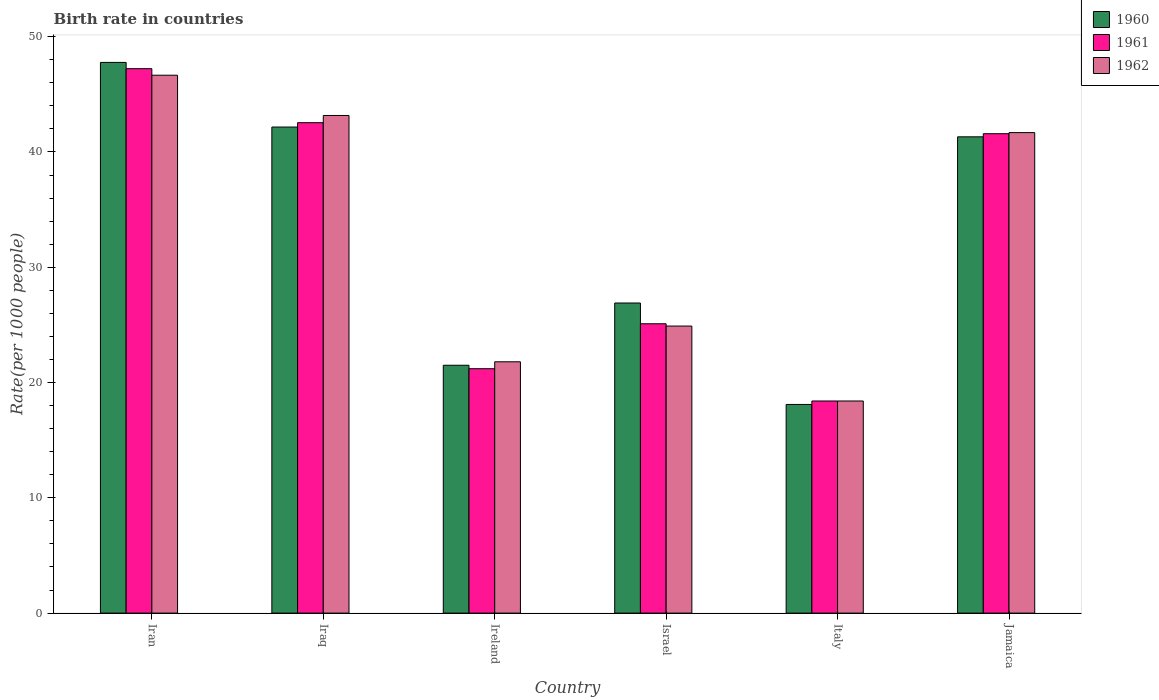How many different coloured bars are there?
Keep it short and to the point. 3. How many groups of bars are there?
Your answer should be very brief. 6. Are the number of bars per tick equal to the number of legend labels?
Keep it short and to the point. Yes. In how many cases, is the number of bars for a given country not equal to the number of legend labels?
Give a very brief answer. 0. What is the birth rate in 1960 in Jamaica?
Keep it short and to the point. 41.32. Across all countries, what is the maximum birth rate in 1962?
Give a very brief answer. 46.66. Across all countries, what is the minimum birth rate in 1962?
Offer a terse response. 18.4. In which country was the birth rate in 1961 maximum?
Give a very brief answer. Iran. What is the total birth rate in 1962 in the graph?
Offer a very short reply. 196.61. What is the difference between the birth rate in 1962 in Ireland and that in Jamaica?
Ensure brevity in your answer.  -19.88. What is the difference between the birth rate in 1962 in Iran and the birth rate in 1961 in Italy?
Provide a short and direct response. 28.26. What is the average birth rate in 1961 per country?
Your response must be concise. 32.68. What is the difference between the birth rate of/in 1960 and birth rate of/in 1962 in Iran?
Give a very brief answer. 1.11. What is the ratio of the birth rate in 1960 in Ireland to that in Jamaica?
Offer a very short reply. 0.52. What is the difference between the highest and the second highest birth rate in 1962?
Offer a terse response. -1.49. What is the difference between the highest and the lowest birth rate in 1960?
Provide a succinct answer. 29.67. In how many countries, is the birth rate in 1960 greater than the average birth rate in 1960 taken over all countries?
Offer a very short reply. 3. What does the 2nd bar from the left in Italy represents?
Give a very brief answer. 1961. How many bars are there?
Keep it short and to the point. 18. Does the graph contain grids?
Provide a succinct answer. No. Where does the legend appear in the graph?
Provide a short and direct response. Top right. How are the legend labels stacked?
Make the answer very short. Vertical. What is the title of the graph?
Your answer should be very brief. Birth rate in countries. What is the label or title of the Y-axis?
Offer a very short reply. Rate(per 1000 people). What is the Rate(per 1000 people) of 1960 in Iran?
Your answer should be compact. 47.77. What is the Rate(per 1000 people) of 1961 in Iran?
Provide a short and direct response. 47.23. What is the Rate(per 1000 people) in 1962 in Iran?
Provide a succinct answer. 46.66. What is the Rate(per 1000 people) of 1960 in Iraq?
Give a very brief answer. 42.16. What is the Rate(per 1000 people) in 1961 in Iraq?
Keep it short and to the point. 42.54. What is the Rate(per 1000 people) of 1962 in Iraq?
Your answer should be very brief. 43.17. What is the Rate(per 1000 people) in 1960 in Ireland?
Keep it short and to the point. 21.5. What is the Rate(per 1000 people) of 1961 in Ireland?
Your response must be concise. 21.2. What is the Rate(per 1000 people) of 1962 in Ireland?
Keep it short and to the point. 21.8. What is the Rate(per 1000 people) in 1960 in Israel?
Make the answer very short. 26.9. What is the Rate(per 1000 people) in 1961 in Israel?
Keep it short and to the point. 25.1. What is the Rate(per 1000 people) in 1962 in Israel?
Provide a short and direct response. 24.9. What is the Rate(per 1000 people) in 1960 in Jamaica?
Provide a succinct answer. 41.32. What is the Rate(per 1000 people) in 1961 in Jamaica?
Offer a terse response. 41.59. What is the Rate(per 1000 people) in 1962 in Jamaica?
Keep it short and to the point. 41.68. Across all countries, what is the maximum Rate(per 1000 people) in 1960?
Your answer should be compact. 47.77. Across all countries, what is the maximum Rate(per 1000 people) in 1961?
Provide a short and direct response. 47.23. Across all countries, what is the maximum Rate(per 1000 people) of 1962?
Offer a very short reply. 46.66. Across all countries, what is the minimum Rate(per 1000 people) in 1960?
Your response must be concise. 18.1. Across all countries, what is the minimum Rate(per 1000 people) in 1962?
Make the answer very short. 18.4. What is the total Rate(per 1000 people) of 1960 in the graph?
Make the answer very short. 197.75. What is the total Rate(per 1000 people) of 1961 in the graph?
Give a very brief answer. 196.06. What is the total Rate(per 1000 people) of 1962 in the graph?
Offer a very short reply. 196.61. What is the difference between the Rate(per 1000 people) in 1960 in Iran and that in Iraq?
Your response must be concise. 5.61. What is the difference between the Rate(per 1000 people) of 1961 in Iran and that in Iraq?
Offer a very short reply. 4.68. What is the difference between the Rate(per 1000 people) of 1962 in Iran and that in Iraq?
Provide a short and direct response. 3.49. What is the difference between the Rate(per 1000 people) of 1960 in Iran and that in Ireland?
Provide a short and direct response. 26.27. What is the difference between the Rate(per 1000 people) of 1961 in Iran and that in Ireland?
Your response must be concise. 26.03. What is the difference between the Rate(per 1000 people) of 1962 in Iran and that in Ireland?
Make the answer very short. 24.86. What is the difference between the Rate(per 1000 people) in 1960 in Iran and that in Israel?
Give a very brief answer. 20.87. What is the difference between the Rate(per 1000 people) of 1961 in Iran and that in Israel?
Give a very brief answer. 22.13. What is the difference between the Rate(per 1000 people) in 1962 in Iran and that in Israel?
Your answer should be very brief. 21.76. What is the difference between the Rate(per 1000 people) of 1960 in Iran and that in Italy?
Your answer should be compact. 29.67. What is the difference between the Rate(per 1000 people) in 1961 in Iran and that in Italy?
Provide a succinct answer. 28.83. What is the difference between the Rate(per 1000 people) of 1962 in Iran and that in Italy?
Provide a succinct answer. 28.26. What is the difference between the Rate(per 1000 people) of 1960 in Iran and that in Jamaica?
Ensure brevity in your answer.  6.46. What is the difference between the Rate(per 1000 people) of 1961 in Iran and that in Jamaica?
Your answer should be compact. 5.64. What is the difference between the Rate(per 1000 people) of 1962 in Iran and that in Jamaica?
Make the answer very short. 4.98. What is the difference between the Rate(per 1000 people) in 1960 in Iraq and that in Ireland?
Your answer should be compact. 20.66. What is the difference between the Rate(per 1000 people) of 1961 in Iraq and that in Ireland?
Your answer should be compact. 21.34. What is the difference between the Rate(per 1000 people) in 1962 in Iraq and that in Ireland?
Make the answer very short. 21.37. What is the difference between the Rate(per 1000 people) of 1960 in Iraq and that in Israel?
Offer a terse response. 15.26. What is the difference between the Rate(per 1000 people) in 1961 in Iraq and that in Israel?
Your answer should be compact. 17.44. What is the difference between the Rate(per 1000 people) of 1962 in Iraq and that in Israel?
Provide a succinct answer. 18.27. What is the difference between the Rate(per 1000 people) in 1960 in Iraq and that in Italy?
Keep it short and to the point. 24.06. What is the difference between the Rate(per 1000 people) in 1961 in Iraq and that in Italy?
Keep it short and to the point. 24.14. What is the difference between the Rate(per 1000 people) in 1962 in Iraq and that in Italy?
Offer a terse response. 24.77. What is the difference between the Rate(per 1000 people) in 1960 in Iraq and that in Jamaica?
Ensure brevity in your answer.  0.85. What is the difference between the Rate(per 1000 people) in 1961 in Iraq and that in Jamaica?
Keep it short and to the point. 0.95. What is the difference between the Rate(per 1000 people) of 1962 in Iraq and that in Jamaica?
Keep it short and to the point. 1.49. What is the difference between the Rate(per 1000 people) of 1961 in Ireland and that in Israel?
Provide a short and direct response. -3.9. What is the difference between the Rate(per 1000 people) of 1960 in Ireland and that in Italy?
Ensure brevity in your answer.  3.4. What is the difference between the Rate(per 1000 people) in 1961 in Ireland and that in Italy?
Keep it short and to the point. 2.8. What is the difference between the Rate(per 1000 people) of 1962 in Ireland and that in Italy?
Your answer should be compact. 3.4. What is the difference between the Rate(per 1000 people) of 1960 in Ireland and that in Jamaica?
Ensure brevity in your answer.  -19.82. What is the difference between the Rate(per 1000 people) in 1961 in Ireland and that in Jamaica?
Your answer should be compact. -20.39. What is the difference between the Rate(per 1000 people) of 1962 in Ireland and that in Jamaica?
Ensure brevity in your answer.  -19.88. What is the difference between the Rate(per 1000 people) in 1960 in Israel and that in Jamaica?
Ensure brevity in your answer.  -14.42. What is the difference between the Rate(per 1000 people) in 1961 in Israel and that in Jamaica?
Make the answer very short. -16.49. What is the difference between the Rate(per 1000 people) in 1962 in Israel and that in Jamaica?
Provide a short and direct response. -16.78. What is the difference between the Rate(per 1000 people) of 1960 in Italy and that in Jamaica?
Provide a short and direct response. -23.22. What is the difference between the Rate(per 1000 people) of 1961 in Italy and that in Jamaica?
Provide a short and direct response. -23.19. What is the difference between the Rate(per 1000 people) in 1962 in Italy and that in Jamaica?
Ensure brevity in your answer.  -23.28. What is the difference between the Rate(per 1000 people) in 1960 in Iran and the Rate(per 1000 people) in 1961 in Iraq?
Ensure brevity in your answer.  5.23. What is the difference between the Rate(per 1000 people) of 1960 in Iran and the Rate(per 1000 people) of 1962 in Iraq?
Your answer should be very brief. 4.6. What is the difference between the Rate(per 1000 people) of 1961 in Iran and the Rate(per 1000 people) of 1962 in Iraq?
Keep it short and to the point. 4.06. What is the difference between the Rate(per 1000 people) in 1960 in Iran and the Rate(per 1000 people) in 1961 in Ireland?
Your response must be concise. 26.57. What is the difference between the Rate(per 1000 people) in 1960 in Iran and the Rate(per 1000 people) in 1962 in Ireland?
Ensure brevity in your answer.  25.97. What is the difference between the Rate(per 1000 people) of 1961 in Iran and the Rate(per 1000 people) of 1962 in Ireland?
Offer a very short reply. 25.43. What is the difference between the Rate(per 1000 people) in 1960 in Iran and the Rate(per 1000 people) in 1961 in Israel?
Provide a short and direct response. 22.67. What is the difference between the Rate(per 1000 people) in 1960 in Iran and the Rate(per 1000 people) in 1962 in Israel?
Give a very brief answer. 22.87. What is the difference between the Rate(per 1000 people) of 1961 in Iran and the Rate(per 1000 people) of 1962 in Israel?
Provide a short and direct response. 22.33. What is the difference between the Rate(per 1000 people) in 1960 in Iran and the Rate(per 1000 people) in 1961 in Italy?
Provide a short and direct response. 29.37. What is the difference between the Rate(per 1000 people) in 1960 in Iran and the Rate(per 1000 people) in 1962 in Italy?
Provide a succinct answer. 29.37. What is the difference between the Rate(per 1000 people) in 1961 in Iran and the Rate(per 1000 people) in 1962 in Italy?
Make the answer very short. 28.83. What is the difference between the Rate(per 1000 people) in 1960 in Iran and the Rate(per 1000 people) in 1961 in Jamaica?
Give a very brief answer. 6.18. What is the difference between the Rate(per 1000 people) of 1960 in Iran and the Rate(per 1000 people) of 1962 in Jamaica?
Give a very brief answer. 6.09. What is the difference between the Rate(per 1000 people) of 1961 in Iran and the Rate(per 1000 people) of 1962 in Jamaica?
Offer a terse response. 5.55. What is the difference between the Rate(per 1000 people) of 1960 in Iraq and the Rate(per 1000 people) of 1961 in Ireland?
Give a very brief answer. 20.96. What is the difference between the Rate(per 1000 people) of 1960 in Iraq and the Rate(per 1000 people) of 1962 in Ireland?
Your response must be concise. 20.36. What is the difference between the Rate(per 1000 people) in 1961 in Iraq and the Rate(per 1000 people) in 1962 in Ireland?
Your response must be concise. 20.74. What is the difference between the Rate(per 1000 people) in 1960 in Iraq and the Rate(per 1000 people) in 1961 in Israel?
Your response must be concise. 17.06. What is the difference between the Rate(per 1000 people) in 1960 in Iraq and the Rate(per 1000 people) in 1962 in Israel?
Your answer should be very brief. 17.26. What is the difference between the Rate(per 1000 people) of 1961 in Iraq and the Rate(per 1000 people) of 1962 in Israel?
Give a very brief answer. 17.64. What is the difference between the Rate(per 1000 people) in 1960 in Iraq and the Rate(per 1000 people) in 1961 in Italy?
Offer a terse response. 23.76. What is the difference between the Rate(per 1000 people) of 1960 in Iraq and the Rate(per 1000 people) of 1962 in Italy?
Ensure brevity in your answer.  23.76. What is the difference between the Rate(per 1000 people) in 1961 in Iraq and the Rate(per 1000 people) in 1962 in Italy?
Your response must be concise. 24.14. What is the difference between the Rate(per 1000 people) in 1960 in Iraq and the Rate(per 1000 people) in 1961 in Jamaica?
Provide a short and direct response. 0.58. What is the difference between the Rate(per 1000 people) of 1960 in Iraq and the Rate(per 1000 people) of 1962 in Jamaica?
Make the answer very short. 0.48. What is the difference between the Rate(per 1000 people) in 1961 in Iraq and the Rate(per 1000 people) in 1962 in Jamaica?
Provide a short and direct response. 0.86. What is the difference between the Rate(per 1000 people) in 1960 in Ireland and the Rate(per 1000 people) in 1962 in Israel?
Provide a short and direct response. -3.4. What is the difference between the Rate(per 1000 people) in 1961 in Ireland and the Rate(per 1000 people) in 1962 in Israel?
Your answer should be very brief. -3.7. What is the difference between the Rate(per 1000 people) in 1960 in Ireland and the Rate(per 1000 people) in 1961 in Jamaica?
Provide a short and direct response. -20.09. What is the difference between the Rate(per 1000 people) in 1960 in Ireland and the Rate(per 1000 people) in 1962 in Jamaica?
Ensure brevity in your answer.  -20.18. What is the difference between the Rate(per 1000 people) of 1961 in Ireland and the Rate(per 1000 people) of 1962 in Jamaica?
Provide a succinct answer. -20.48. What is the difference between the Rate(per 1000 people) of 1960 in Israel and the Rate(per 1000 people) of 1962 in Italy?
Provide a short and direct response. 8.5. What is the difference between the Rate(per 1000 people) in 1960 in Israel and the Rate(per 1000 people) in 1961 in Jamaica?
Ensure brevity in your answer.  -14.69. What is the difference between the Rate(per 1000 people) of 1960 in Israel and the Rate(per 1000 people) of 1962 in Jamaica?
Your response must be concise. -14.78. What is the difference between the Rate(per 1000 people) of 1961 in Israel and the Rate(per 1000 people) of 1962 in Jamaica?
Your answer should be very brief. -16.58. What is the difference between the Rate(per 1000 people) in 1960 in Italy and the Rate(per 1000 people) in 1961 in Jamaica?
Your answer should be very brief. -23.49. What is the difference between the Rate(per 1000 people) in 1960 in Italy and the Rate(per 1000 people) in 1962 in Jamaica?
Make the answer very short. -23.58. What is the difference between the Rate(per 1000 people) of 1961 in Italy and the Rate(per 1000 people) of 1962 in Jamaica?
Provide a succinct answer. -23.28. What is the average Rate(per 1000 people) in 1960 per country?
Offer a very short reply. 32.96. What is the average Rate(per 1000 people) in 1961 per country?
Keep it short and to the point. 32.68. What is the average Rate(per 1000 people) of 1962 per country?
Provide a succinct answer. 32.77. What is the difference between the Rate(per 1000 people) in 1960 and Rate(per 1000 people) in 1961 in Iran?
Provide a succinct answer. 0.54. What is the difference between the Rate(per 1000 people) of 1960 and Rate(per 1000 people) of 1962 in Iran?
Keep it short and to the point. 1.11. What is the difference between the Rate(per 1000 people) of 1961 and Rate(per 1000 people) of 1962 in Iran?
Your answer should be compact. 0.57. What is the difference between the Rate(per 1000 people) of 1960 and Rate(per 1000 people) of 1961 in Iraq?
Give a very brief answer. -0.38. What is the difference between the Rate(per 1000 people) of 1960 and Rate(per 1000 people) of 1962 in Iraq?
Your response must be concise. -1. What is the difference between the Rate(per 1000 people) in 1961 and Rate(per 1000 people) in 1962 in Iraq?
Your answer should be compact. -0.62. What is the difference between the Rate(per 1000 people) in 1960 and Rate(per 1000 people) in 1961 in Ireland?
Offer a terse response. 0.3. What is the difference between the Rate(per 1000 people) in 1960 and Rate(per 1000 people) in 1962 in Ireland?
Your response must be concise. -0.3. What is the difference between the Rate(per 1000 people) of 1961 and Rate(per 1000 people) of 1962 in Ireland?
Your answer should be very brief. -0.6. What is the difference between the Rate(per 1000 people) of 1960 and Rate(per 1000 people) of 1961 in Israel?
Offer a very short reply. 1.8. What is the difference between the Rate(per 1000 people) of 1961 and Rate(per 1000 people) of 1962 in Israel?
Give a very brief answer. 0.2. What is the difference between the Rate(per 1000 people) in 1960 and Rate(per 1000 people) in 1961 in Italy?
Provide a short and direct response. -0.3. What is the difference between the Rate(per 1000 people) of 1960 and Rate(per 1000 people) of 1962 in Italy?
Give a very brief answer. -0.3. What is the difference between the Rate(per 1000 people) of 1961 and Rate(per 1000 people) of 1962 in Italy?
Offer a very short reply. 0. What is the difference between the Rate(per 1000 people) in 1960 and Rate(per 1000 people) in 1961 in Jamaica?
Keep it short and to the point. -0.27. What is the difference between the Rate(per 1000 people) of 1960 and Rate(per 1000 people) of 1962 in Jamaica?
Provide a short and direct response. -0.36. What is the difference between the Rate(per 1000 people) in 1961 and Rate(per 1000 people) in 1962 in Jamaica?
Provide a short and direct response. -0.09. What is the ratio of the Rate(per 1000 people) in 1960 in Iran to that in Iraq?
Ensure brevity in your answer.  1.13. What is the ratio of the Rate(per 1000 people) of 1961 in Iran to that in Iraq?
Provide a short and direct response. 1.11. What is the ratio of the Rate(per 1000 people) in 1962 in Iran to that in Iraq?
Provide a short and direct response. 1.08. What is the ratio of the Rate(per 1000 people) of 1960 in Iran to that in Ireland?
Provide a succinct answer. 2.22. What is the ratio of the Rate(per 1000 people) in 1961 in Iran to that in Ireland?
Ensure brevity in your answer.  2.23. What is the ratio of the Rate(per 1000 people) of 1962 in Iran to that in Ireland?
Provide a succinct answer. 2.14. What is the ratio of the Rate(per 1000 people) in 1960 in Iran to that in Israel?
Offer a very short reply. 1.78. What is the ratio of the Rate(per 1000 people) in 1961 in Iran to that in Israel?
Make the answer very short. 1.88. What is the ratio of the Rate(per 1000 people) of 1962 in Iran to that in Israel?
Ensure brevity in your answer.  1.87. What is the ratio of the Rate(per 1000 people) in 1960 in Iran to that in Italy?
Offer a very short reply. 2.64. What is the ratio of the Rate(per 1000 people) in 1961 in Iran to that in Italy?
Offer a terse response. 2.57. What is the ratio of the Rate(per 1000 people) of 1962 in Iran to that in Italy?
Your response must be concise. 2.54. What is the ratio of the Rate(per 1000 people) in 1960 in Iran to that in Jamaica?
Provide a succinct answer. 1.16. What is the ratio of the Rate(per 1000 people) in 1961 in Iran to that in Jamaica?
Your answer should be compact. 1.14. What is the ratio of the Rate(per 1000 people) in 1962 in Iran to that in Jamaica?
Keep it short and to the point. 1.12. What is the ratio of the Rate(per 1000 people) of 1960 in Iraq to that in Ireland?
Make the answer very short. 1.96. What is the ratio of the Rate(per 1000 people) in 1961 in Iraq to that in Ireland?
Your answer should be very brief. 2.01. What is the ratio of the Rate(per 1000 people) in 1962 in Iraq to that in Ireland?
Give a very brief answer. 1.98. What is the ratio of the Rate(per 1000 people) of 1960 in Iraq to that in Israel?
Your response must be concise. 1.57. What is the ratio of the Rate(per 1000 people) in 1961 in Iraq to that in Israel?
Offer a very short reply. 1.69. What is the ratio of the Rate(per 1000 people) of 1962 in Iraq to that in Israel?
Your answer should be compact. 1.73. What is the ratio of the Rate(per 1000 people) of 1960 in Iraq to that in Italy?
Keep it short and to the point. 2.33. What is the ratio of the Rate(per 1000 people) of 1961 in Iraq to that in Italy?
Your response must be concise. 2.31. What is the ratio of the Rate(per 1000 people) in 1962 in Iraq to that in Italy?
Offer a very short reply. 2.35. What is the ratio of the Rate(per 1000 people) in 1960 in Iraq to that in Jamaica?
Your answer should be compact. 1.02. What is the ratio of the Rate(per 1000 people) of 1961 in Iraq to that in Jamaica?
Your response must be concise. 1.02. What is the ratio of the Rate(per 1000 people) of 1962 in Iraq to that in Jamaica?
Keep it short and to the point. 1.04. What is the ratio of the Rate(per 1000 people) in 1960 in Ireland to that in Israel?
Your answer should be very brief. 0.8. What is the ratio of the Rate(per 1000 people) in 1961 in Ireland to that in Israel?
Offer a terse response. 0.84. What is the ratio of the Rate(per 1000 people) of 1962 in Ireland to that in Israel?
Provide a short and direct response. 0.88. What is the ratio of the Rate(per 1000 people) in 1960 in Ireland to that in Italy?
Ensure brevity in your answer.  1.19. What is the ratio of the Rate(per 1000 people) of 1961 in Ireland to that in Italy?
Make the answer very short. 1.15. What is the ratio of the Rate(per 1000 people) of 1962 in Ireland to that in Italy?
Offer a terse response. 1.18. What is the ratio of the Rate(per 1000 people) in 1960 in Ireland to that in Jamaica?
Your answer should be very brief. 0.52. What is the ratio of the Rate(per 1000 people) of 1961 in Ireland to that in Jamaica?
Provide a short and direct response. 0.51. What is the ratio of the Rate(per 1000 people) in 1962 in Ireland to that in Jamaica?
Your answer should be very brief. 0.52. What is the ratio of the Rate(per 1000 people) in 1960 in Israel to that in Italy?
Give a very brief answer. 1.49. What is the ratio of the Rate(per 1000 people) in 1961 in Israel to that in Italy?
Your answer should be very brief. 1.36. What is the ratio of the Rate(per 1000 people) in 1962 in Israel to that in Italy?
Give a very brief answer. 1.35. What is the ratio of the Rate(per 1000 people) in 1960 in Israel to that in Jamaica?
Ensure brevity in your answer.  0.65. What is the ratio of the Rate(per 1000 people) in 1961 in Israel to that in Jamaica?
Offer a terse response. 0.6. What is the ratio of the Rate(per 1000 people) in 1962 in Israel to that in Jamaica?
Provide a succinct answer. 0.6. What is the ratio of the Rate(per 1000 people) of 1960 in Italy to that in Jamaica?
Offer a terse response. 0.44. What is the ratio of the Rate(per 1000 people) of 1961 in Italy to that in Jamaica?
Your response must be concise. 0.44. What is the ratio of the Rate(per 1000 people) in 1962 in Italy to that in Jamaica?
Your answer should be compact. 0.44. What is the difference between the highest and the second highest Rate(per 1000 people) in 1960?
Offer a very short reply. 5.61. What is the difference between the highest and the second highest Rate(per 1000 people) in 1961?
Your answer should be very brief. 4.68. What is the difference between the highest and the second highest Rate(per 1000 people) in 1962?
Provide a succinct answer. 3.49. What is the difference between the highest and the lowest Rate(per 1000 people) in 1960?
Provide a short and direct response. 29.67. What is the difference between the highest and the lowest Rate(per 1000 people) in 1961?
Keep it short and to the point. 28.83. What is the difference between the highest and the lowest Rate(per 1000 people) in 1962?
Your response must be concise. 28.26. 